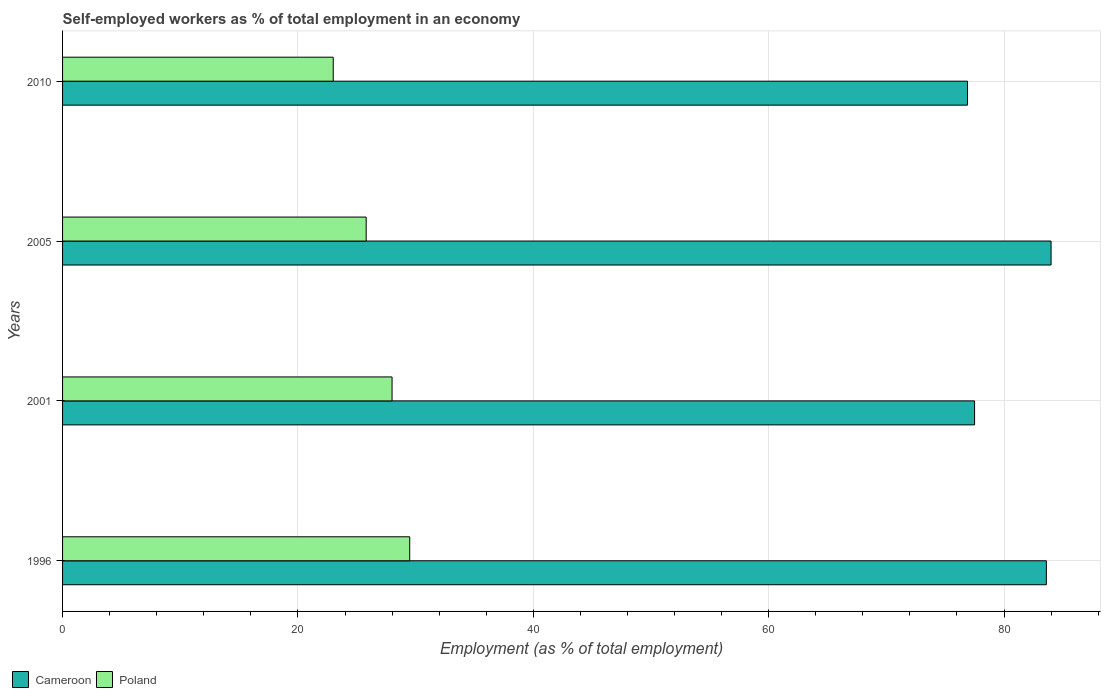How many different coloured bars are there?
Provide a succinct answer. 2. How many groups of bars are there?
Your response must be concise. 4. How many bars are there on the 1st tick from the top?
Keep it short and to the point. 2. What is the label of the 3rd group of bars from the top?
Keep it short and to the point. 2001. In how many cases, is the number of bars for a given year not equal to the number of legend labels?
Ensure brevity in your answer.  0. What is the percentage of self-employed workers in Poland in 1996?
Your answer should be compact. 29.5. Across all years, what is the maximum percentage of self-employed workers in Poland?
Provide a short and direct response. 29.5. In which year was the percentage of self-employed workers in Poland maximum?
Provide a succinct answer. 1996. In which year was the percentage of self-employed workers in Cameroon minimum?
Your answer should be very brief. 2010. What is the total percentage of self-employed workers in Poland in the graph?
Provide a short and direct response. 106.3. What is the difference between the percentage of self-employed workers in Cameroon in 1996 and that in 2001?
Give a very brief answer. 6.1. What is the difference between the percentage of self-employed workers in Poland in 2010 and the percentage of self-employed workers in Cameroon in 2005?
Give a very brief answer. -61. What is the average percentage of self-employed workers in Cameroon per year?
Give a very brief answer. 80.5. In the year 2005, what is the difference between the percentage of self-employed workers in Cameroon and percentage of self-employed workers in Poland?
Your answer should be very brief. 58.2. In how many years, is the percentage of self-employed workers in Cameroon greater than 8 %?
Make the answer very short. 4. What is the ratio of the percentage of self-employed workers in Poland in 2001 to that in 2005?
Keep it short and to the point. 1.09. Is the difference between the percentage of self-employed workers in Cameroon in 1996 and 2010 greater than the difference between the percentage of self-employed workers in Poland in 1996 and 2010?
Your response must be concise. Yes. What is the difference between the highest and the second highest percentage of self-employed workers in Cameroon?
Ensure brevity in your answer.  0.4. What is the difference between the highest and the lowest percentage of self-employed workers in Cameroon?
Your answer should be compact. 7.1. Is the sum of the percentage of self-employed workers in Cameroon in 2001 and 2010 greater than the maximum percentage of self-employed workers in Poland across all years?
Give a very brief answer. Yes. What does the 2nd bar from the bottom in 2001 represents?
Keep it short and to the point. Poland. Are all the bars in the graph horizontal?
Your answer should be compact. Yes. How many years are there in the graph?
Your response must be concise. 4. What is the difference between two consecutive major ticks on the X-axis?
Give a very brief answer. 20. Are the values on the major ticks of X-axis written in scientific E-notation?
Make the answer very short. No. Where does the legend appear in the graph?
Offer a terse response. Bottom left. How many legend labels are there?
Offer a very short reply. 2. How are the legend labels stacked?
Your answer should be very brief. Horizontal. What is the title of the graph?
Keep it short and to the point. Self-employed workers as % of total employment in an economy. Does "Sweden" appear as one of the legend labels in the graph?
Keep it short and to the point. No. What is the label or title of the X-axis?
Provide a short and direct response. Employment (as % of total employment). What is the label or title of the Y-axis?
Provide a short and direct response. Years. What is the Employment (as % of total employment) of Cameroon in 1996?
Ensure brevity in your answer.  83.6. What is the Employment (as % of total employment) in Poland in 1996?
Make the answer very short. 29.5. What is the Employment (as % of total employment) of Cameroon in 2001?
Provide a short and direct response. 77.5. What is the Employment (as % of total employment) in Poland in 2005?
Make the answer very short. 25.8. What is the Employment (as % of total employment) of Cameroon in 2010?
Offer a terse response. 76.9. Across all years, what is the maximum Employment (as % of total employment) of Poland?
Your answer should be very brief. 29.5. Across all years, what is the minimum Employment (as % of total employment) in Cameroon?
Provide a succinct answer. 76.9. Across all years, what is the minimum Employment (as % of total employment) of Poland?
Ensure brevity in your answer.  23. What is the total Employment (as % of total employment) in Cameroon in the graph?
Your answer should be compact. 322. What is the total Employment (as % of total employment) of Poland in the graph?
Ensure brevity in your answer.  106.3. What is the difference between the Employment (as % of total employment) of Poland in 1996 and that in 2001?
Offer a very short reply. 1.5. What is the difference between the Employment (as % of total employment) of Poland in 1996 and that in 2005?
Provide a short and direct response. 3.7. What is the difference between the Employment (as % of total employment) in Cameroon in 1996 and that in 2010?
Offer a terse response. 6.7. What is the difference between the Employment (as % of total employment) of Cameroon in 2001 and that in 2010?
Your response must be concise. 0.6. What is the difference between the Employment (as % of total employment) in Poland in 2001 and that in 2010?
Offer a very short reply. 5. What is the difference between the Employment (as % of total employment) of Cameroon in 1996 and the Employment (as % of total employment) of Poland in 2001?
Give a very brief answer. 55.6. What is the difference between the Employment (as % of total employment) of Cameroon in 1996 and the Employment (as % of total employment) of Poland in 2005?
Provide a succinct answer. 57.8. What is the difference between the Employment (as % of total employment) of Cameroon in 1996 and the Employment (as % of total employment) of Poland in 2010?
Your answer should be very brief. 60.6. What is the difference between the Employment (as % of total employment) of Cameroon in 2001 and the Employment (as % of total employment) of Poland in 2005?
Your response must be concise. 51.7. What is the difference between the Employment (as % of total employment) of Cameroon in 2001 and the Employment (as % of total employment) of Poland in 2010?
Offer a very short reply. 54.5. What is the difference between the Employment (as % of total employment) of Cameroon in 2005 and the Employment (as % of total employment) of Poland in 2010?
Make the answer very short. 61. What is the average Employment (as % of total employment) in Cameroon per year?
Your response must be concise. 80.5. What is the average Employment (as % of total employment) in Poland per year?
Give a very brief answer. 26.57. In the year 1996, what is the difference between the Employment (as % of total employment) of Cameroon and Employment (as % of total employment) of Poland?
Provide a short and direct response. 54.1. In the year 2001, what is the difference between the Employment (as % of total employment) in Cameroon and Employment (as % of total employment) in Poland?
Ensure brevity in your answer.  49.5. In the year 2005, what is the difference between the Employment (as % of total employment) of Cameroon and Employment (as % of total employment) of Poland?
Offer a terse response. 58.2. In the year 2010, what is the difference between the Employment (as % of total employment) of Cameroon and Employment (as % of total employment) of Poland?
Your answer should be very brief. 53.9. What is the ratio of the Employment (as % of total employment) in Cameroon in 1996 to that in 2001?
Offer a terse response. 1.08. What is the ratio of the Employment (as % of total employment) in Poland in 1996 to that in 2001?
Ensure brevity in your answer.  1.05. What is the ratio of the Employment (as % of total employment) in Poland in 1996 to that in 2005?
Provide a succinct answer. 1.14. What is the ratio of the Employment (as % of total employment) of Cameroon in 1996 to that in 2010?
Your response must be concise. 1.09. What is the ratio of the Employment (as % of total employment) of Poland in 1996 to that in 2010?
Offer a very short reply. 1.28. What is the ratio of the Employment (as % of total employment) of Cameroon in 2001 to that in 2005?
Give a very brief answer. 0.92. What is the ratio of the Employment (as % of total employment) of Poland in 2001 to that in 2005?
Ensure brevity in your answer.  1.09. What is the ratio of the Employment (as % of total employment) of Poland in 2001 to that in 2010?
Provide a short and direct response. 1.22. What is the ratio of the Employment (as % of total employment) of Cameroon in 2005 to that in 2010?
Offer a very short reply. 1.09. What is the ratio of the Employment (as % of total employment) in Poland in 2005 to that in 2010?
Your response must be concise. 1.12. What is the difference between the highest and the second highest Employment (as % of total employment) in Poland?
Your answer should be compact. 1.5. 